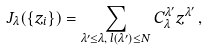<formula> <loc_0><loc_0><loc_500><loc_500>J _ { \lambda } ( \{ z _ { i } \} ) = \sum _ { \lambda ^ { \prime } \leq \lambda , \, l ( \lambda ^ { \prime } ) \leq N } C _ { \lambda } ^ { \lambda ^ { \prime } } z ^ { \lambda ^ { \prime } } \, ,</formula> 